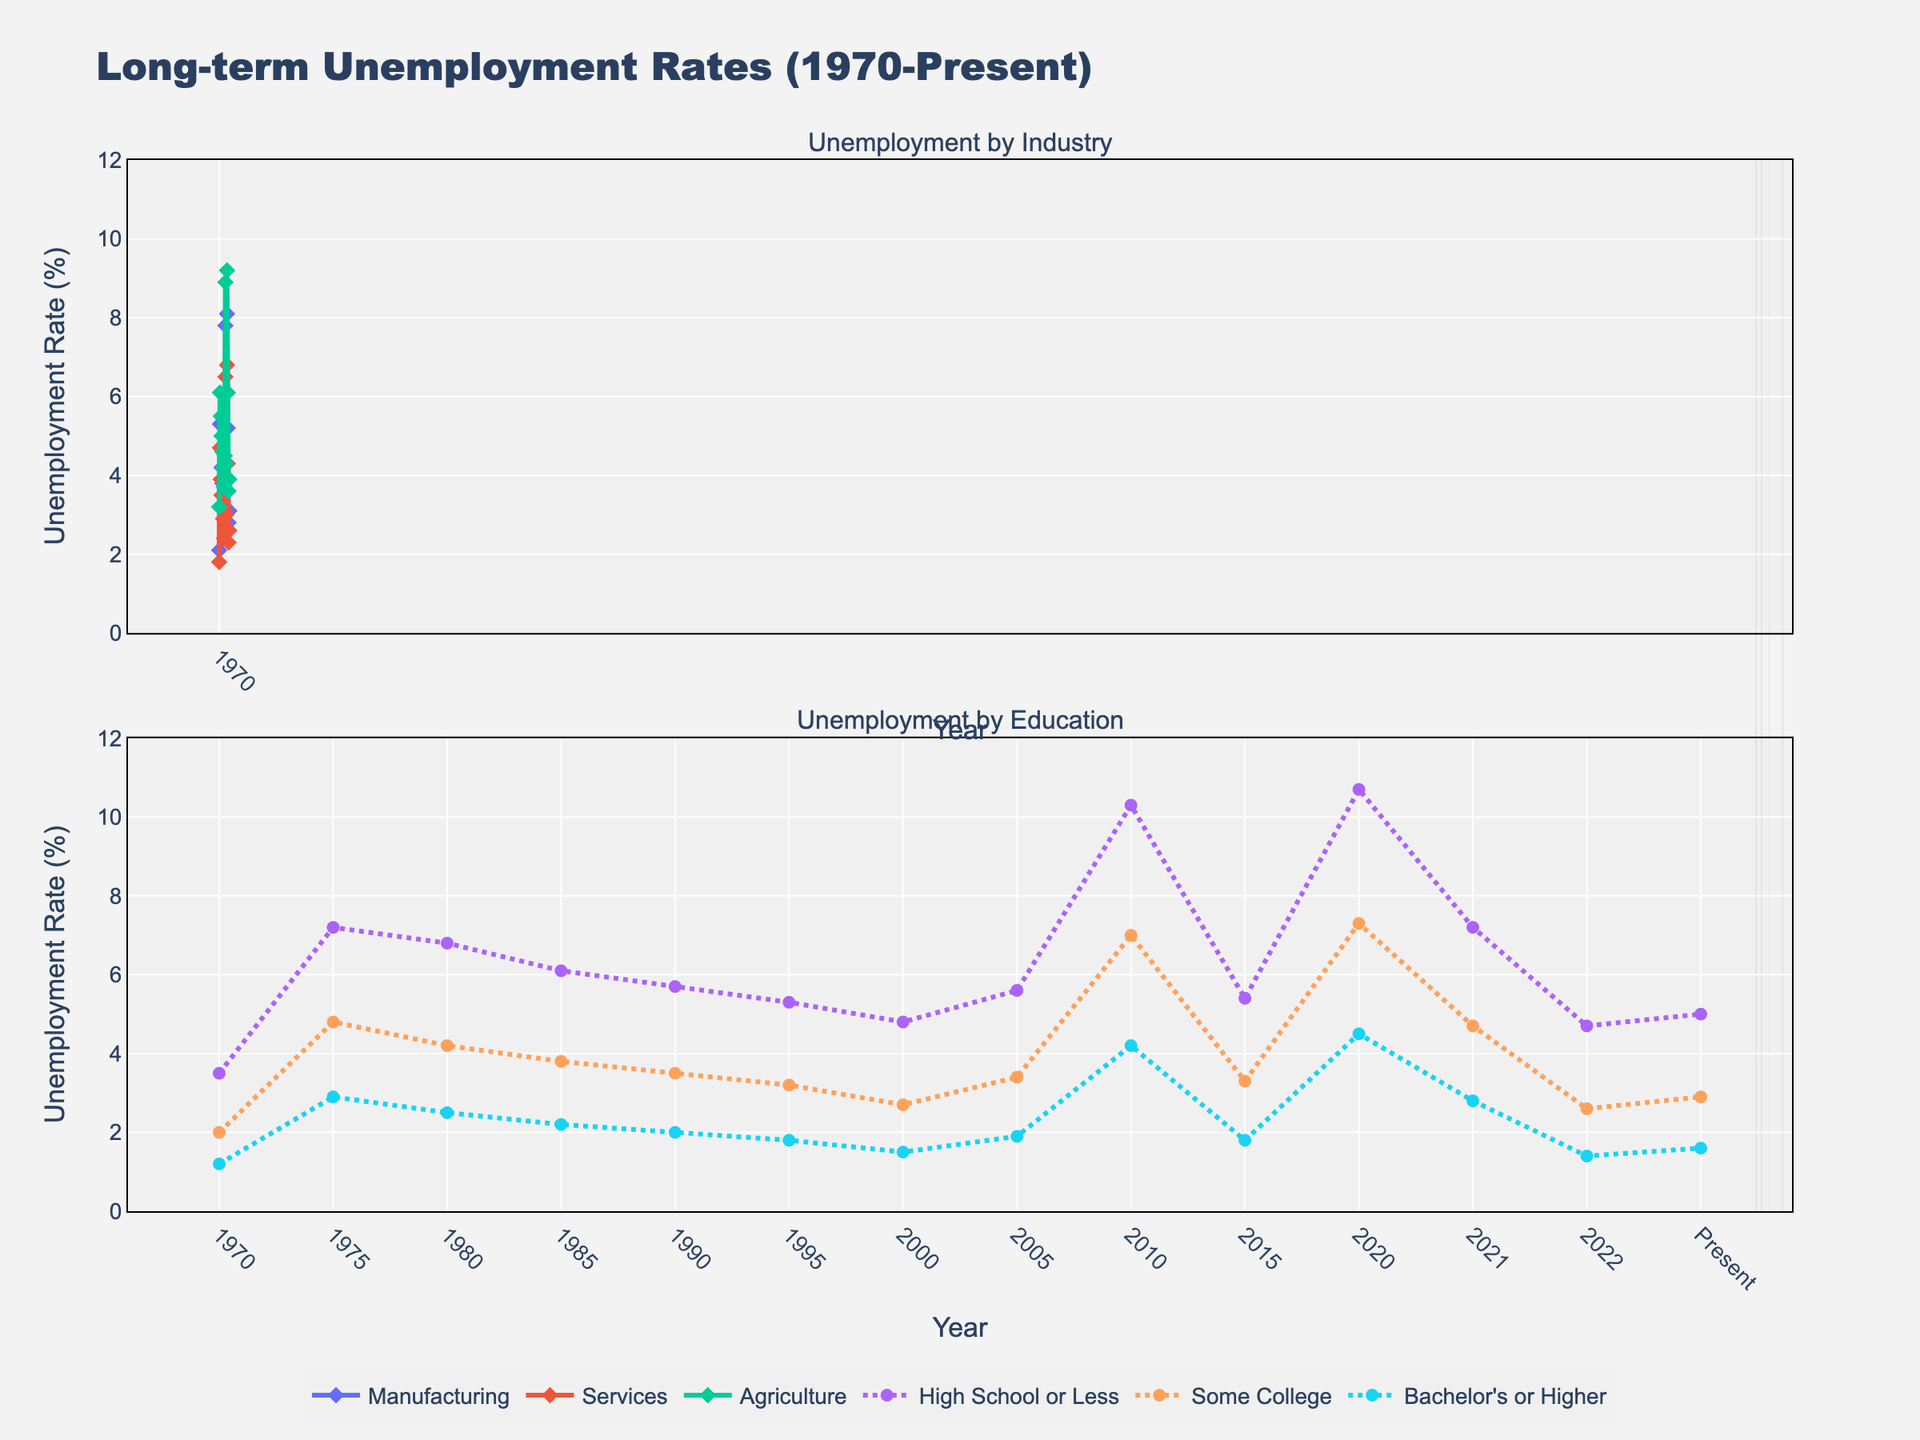Which industry experienced the highest unemployment rate in 1980? By examining the graph, locate the unemployment rate for Manufacturing, Services, and Agriculture in 1980. Among these, Agriculture has the highest rate.
Answer: Agriculture Did the unemployment rate for people with a Bachelor's or Higher degree ever exceed 5%? Looking at the plot lines for Bachelor's or Higher from 1970 to the present, the line never crosses the 5% mark.
Answer: No During which recession period did the unemployment rate in Manufacturing peak the highest? Observe the shaded areas that represent recession periods and check the corresponding peaks in the Manufacturing line. The highest peak occurs during the 2007-2009 recession.
Answer: 2007-2009 What's the average unemployment rate for Services between 2000 and 2010? Find the unemployment rates for Services in 2000, 2005, and 2010, then calculate the average: (2.4 + 3.1 + 6.5) / 3 = 4
Answer: 4 How did the unemployment rate change for those with High School or Less from 1975 to 1980? Check the line for High School or Less at 1975 and 1980. It goes from 7.2% to 6.8%, indicating a decrease of 0.4%.
Answer: Decreased by 0.4% Compare the unemployment rate trends for Agriculture and Services from 2010 to the present. Which had a steeper decline? Assess the slopes of the lines for Agriculture and Services between 2010 and present. Agriculture significantly decreases from 8.9% to 3.9% while Services decreases from 6.5% to 2.6%. The decrease in Agriculture is steeper.
Answer: Agriculture What's the difference in unemployment rates between High School or Less and Bachelor's or Higher in 2020? Find the values for High School or Less and Bachelor's or Higher in 2020: 10.7% and 4.5% respectively. The difference is 10.7 - 4.5 = 6.2%.
Answer: 6.2% Which educational background had the smallest variation in unemployment rates between 1970 and the present? Compare the range (maximum - minimum) of unemployment rates for each educational background: High School or Less (10.7% - 4.7%), Some College (7.3% - 2.0%), Bachelor's or Higher (4.5% - 1.2%). Bachelor's or Higher has the smallest range.
Answer: Bachelor's or Higher During the recession period of 2020, which industry had the closest unemployment rate to the overall unemployment rate for Some College? Find the unemployment rate for Some College in 2020 (7.3%) and check which industry’s unemployment rate is closest to this value. Services at 6.8% is the closest.
Answer: Services 